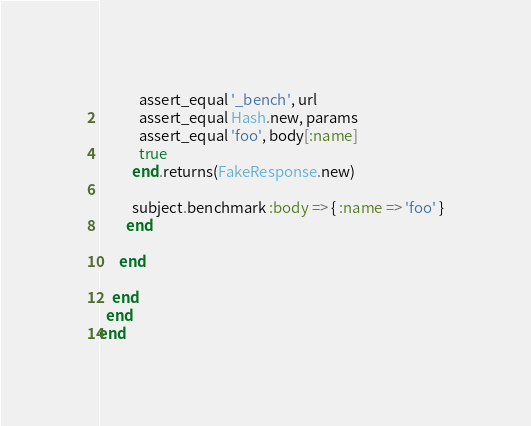<code> <loc_0><loc_0><loc_500><loc_500><_Ruby_>            assert_equal '_bench', url
            assert_equal Hash.new, params
            assert_equal 'foo', body[:name]
            true
          end.returns(FakeResponse.new)

          subject.benchmark :body => { :name => 'foo' }
        end

      end

    end
  end
end
</code> 